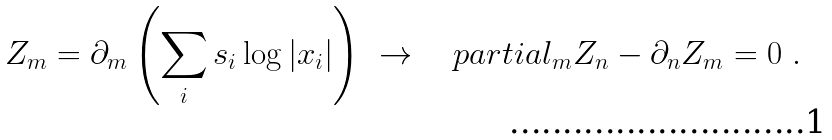<formula> <loc_0><loc_0><loc_500><loc_500>Z _ { m } = \partial _ { m } \left ( \sum _ { i } s _ { i } \log | x _ { i } | \right ) \ \rightarrow \ \ \ p a r t i a l _ { m } Z _ { n } - \partial _ { n } Z _ { m } = 0 \ .</formula> 